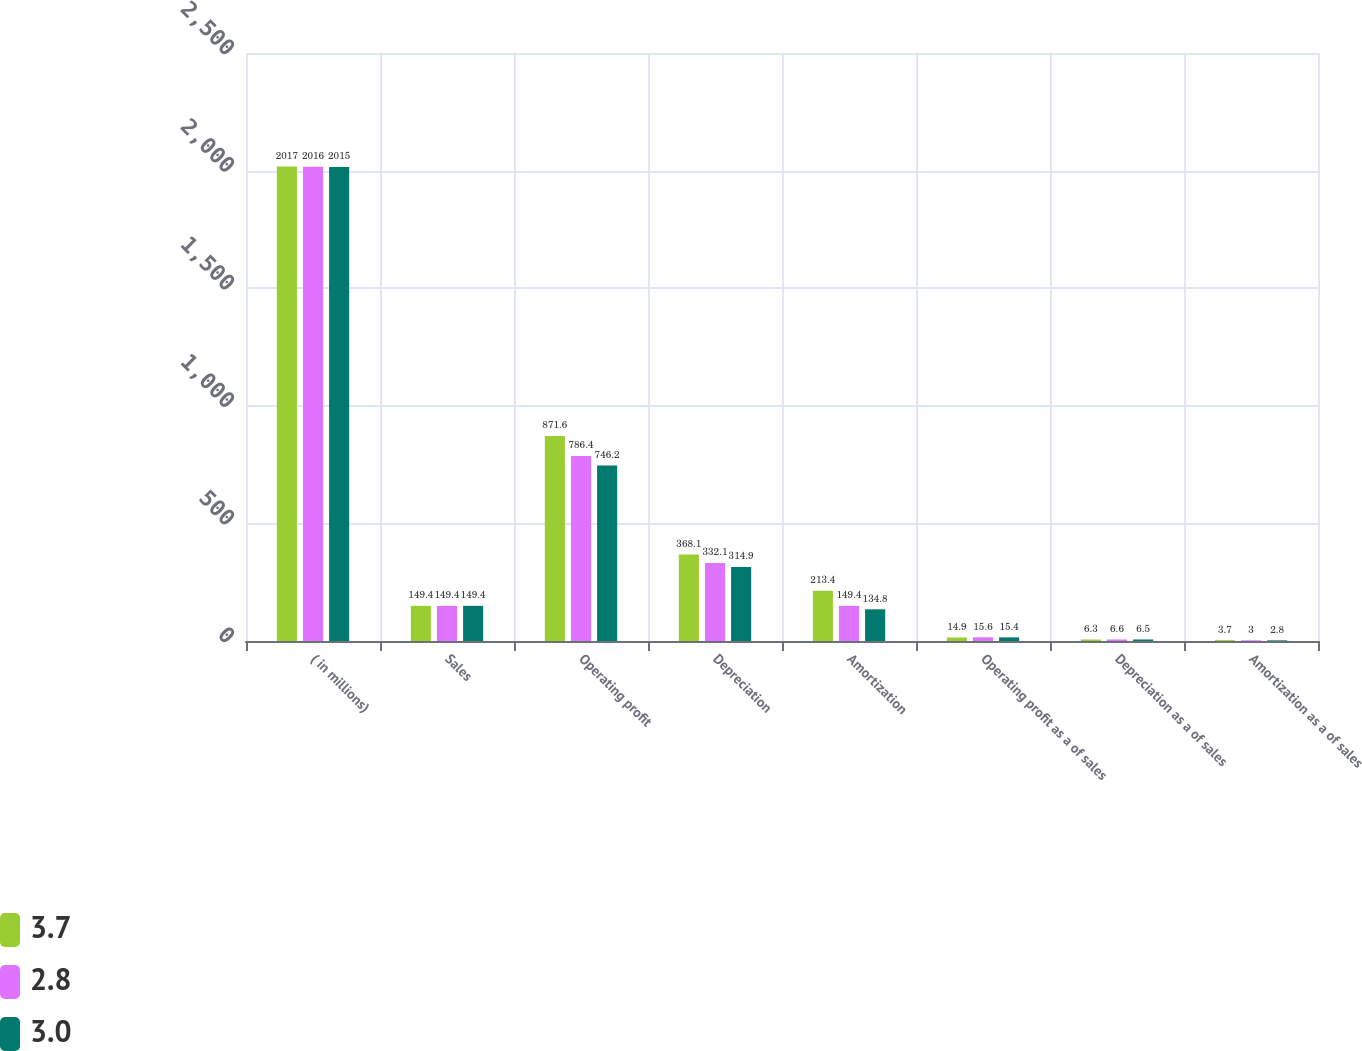Convert chart to OTSL. <chart><loc_0><loc_0><loc_500><loc_500><stacked_bar_chart><ecel><fcel>( in millions)<fcel>Sales<fcel>Operating profit<fcel>Depreciation<fcel>Amortization<fcel>Operating profit as a of sales<fcel>Depreciation as a of sales<fcel>Amortization as a of sales<nl><fcel>3.7<fcel>2017<fcel>149.4<fcel>871.6<fcel>368.1<fcel>213.4<fcel>14.9<fcel>6.3<fcel>3.7<nl><fcel>2.8<fcel>2016<fcel>149.4<fcel>786.4<fcel>332.1<fcel>149.4<fcel>15.6<fcel>6.6<fcel>3<nl><fcel>3<fcel>2015<fcel>149.4<fcel>746.2<fcel>314.9<fcel>134.8<fcel>15.4<fcel>6.5<fcel>2.8<nl></chart> 